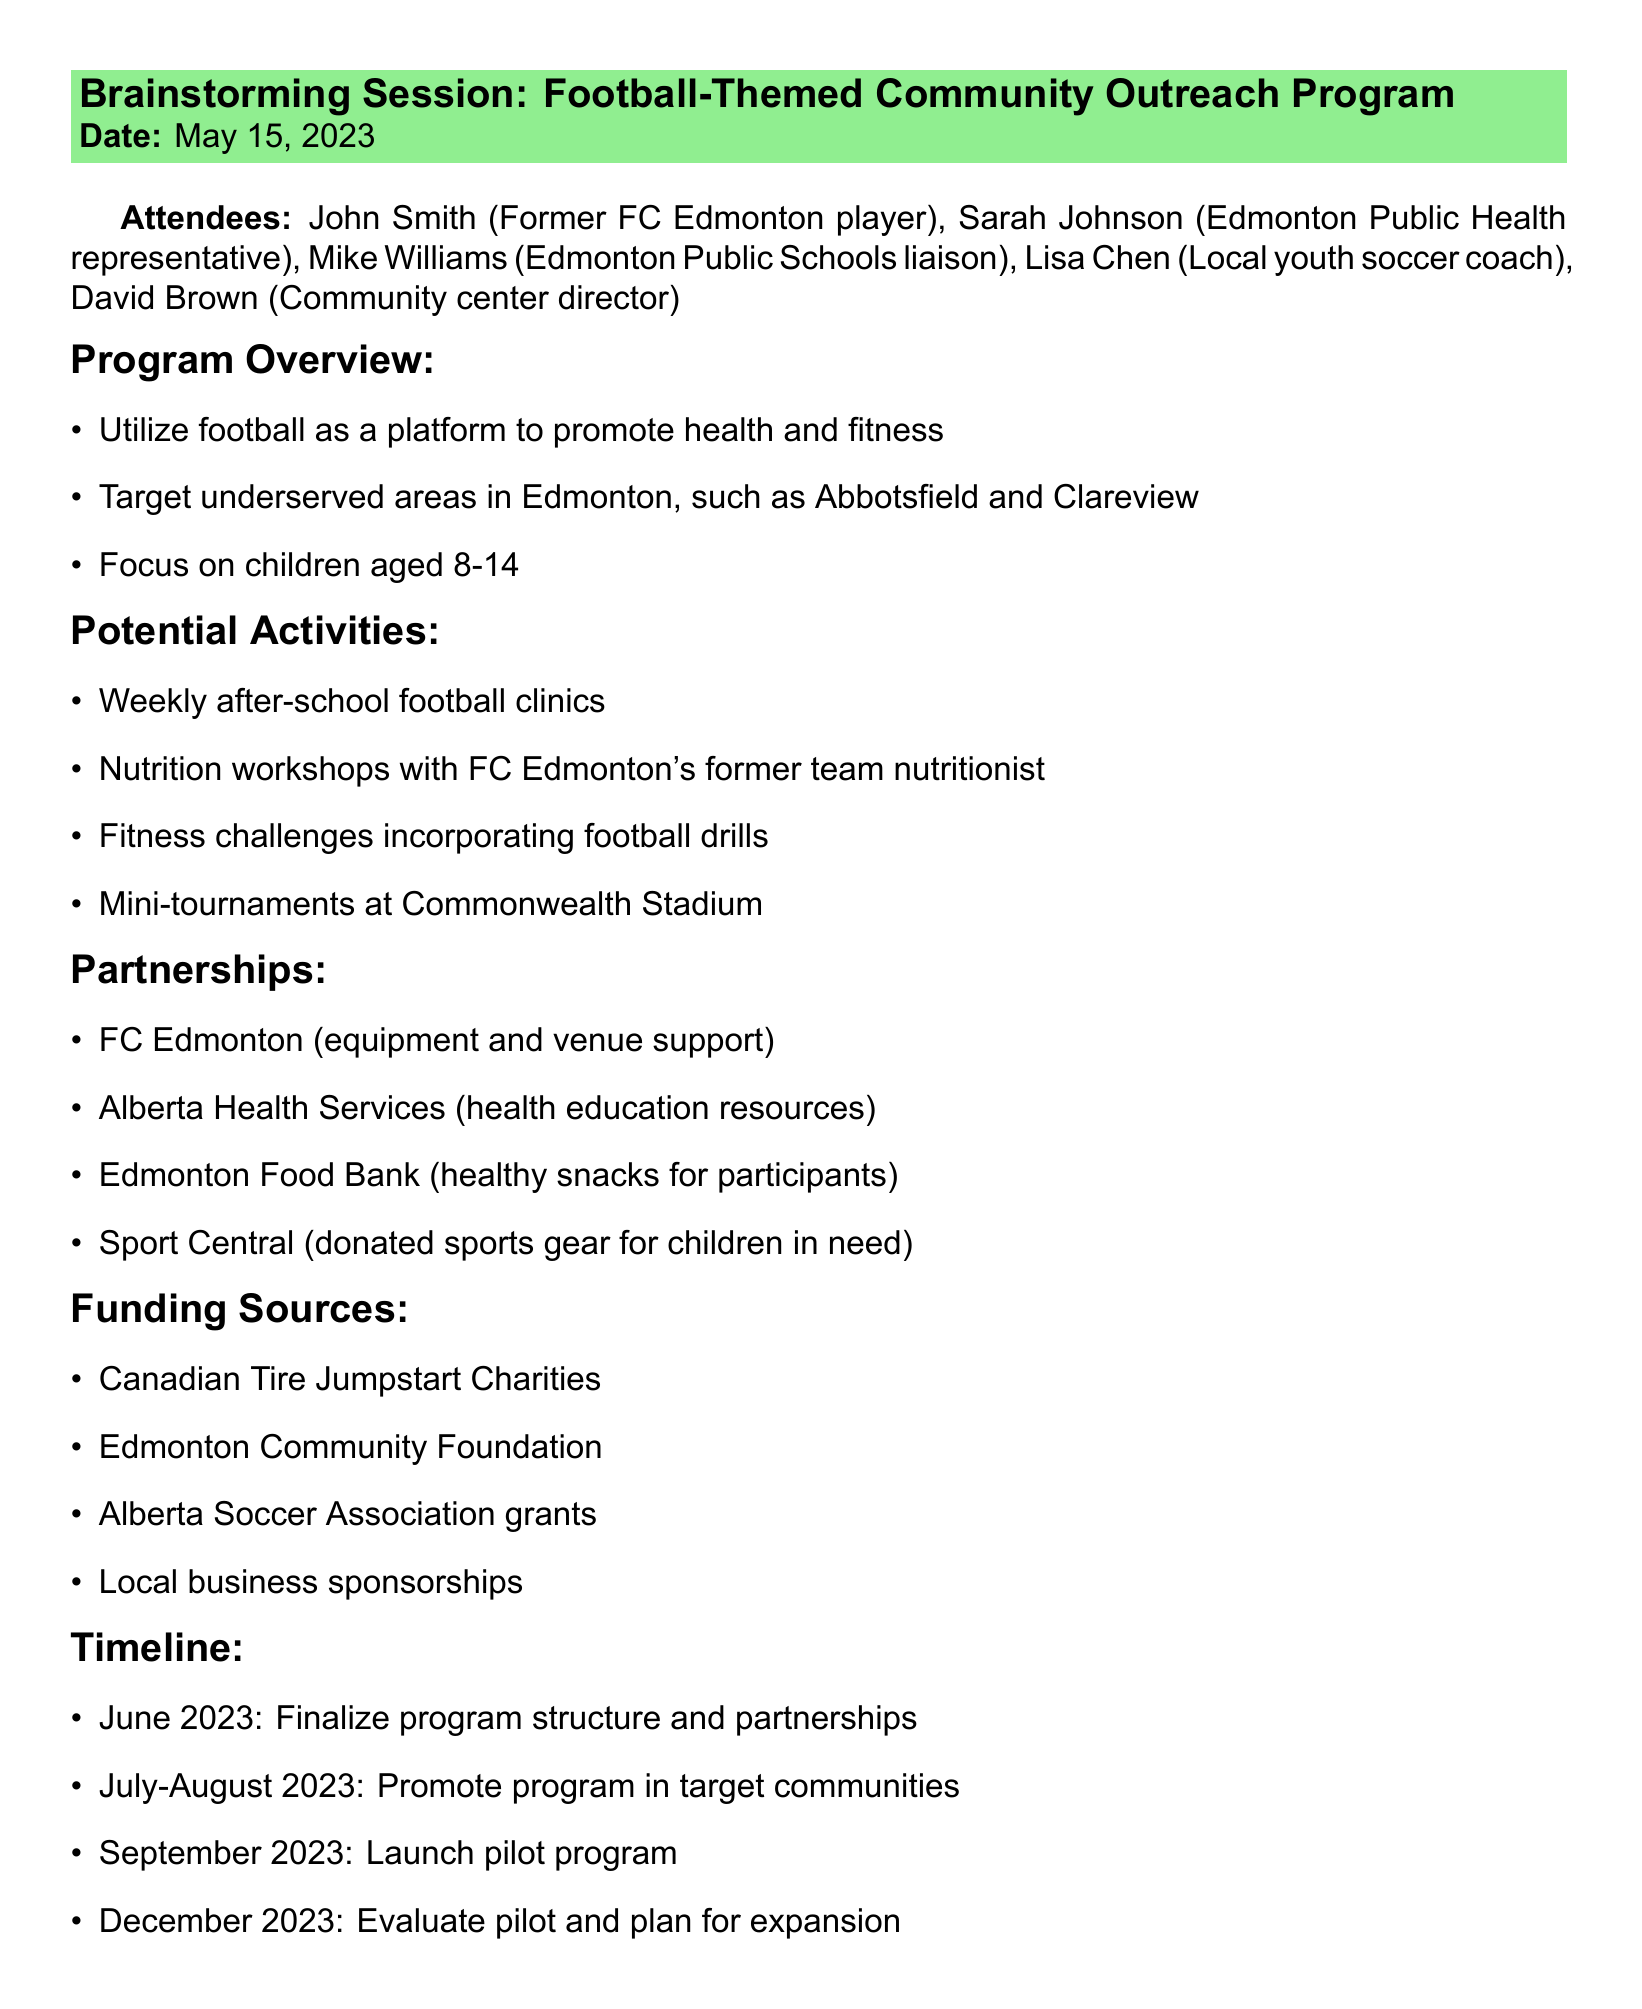What is the date of the meeting? The date of the meeting is explicitly mentioned in the document.
Answer: May 15, 2023 Who represents Edmonton Public Health? The attendees section lists Sarah Johnson as the representative from Edmonton Public Health.
Answer: Sarah Johnson What is one of the potential activities mentioned? The section on Potential Activities lists several ideas, any of which can be used as an answer.
Answer: Weekly after-school football clinics Which areas is the program targeting? The program overview specifies locations that the program aims to focus on, listed in the document.
Answer: Abbotsfield and Clareview What is the first milestone in the timeline? The timeline section outlines specific dates and corresponding milestones.
Answer: June 2023 How many attendees are listed in total? The attendees section lists the number of people present at the meeting.
Answer: Five What organization is suggested for health education resources? The Partnerships section highlights potential partners, including specific organizations for health education.
Answer: Alberta Health Services How many action items are there? The Action Items section details the next steps for attendees, which reflects the total number of specific tasks.
Answer: Five What type of workshops are planned? The Potential Activities section mentions specific types of workshops designed for the program.
Answer: Nutrition workshops 